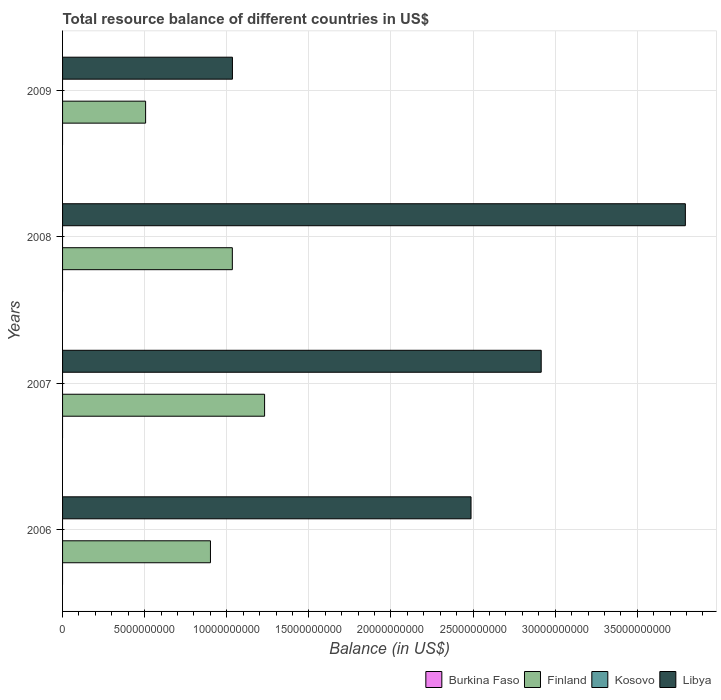How many different coloured bars are there?
Provide a short and direct response. 2. Are the number of bars on each tick of the Y-axis equal?
Provide a succinct answer. Yes. How many bars are there on the 4th tick from the top?
Your response must be concise. 2. What is the label of the 2nd group of bars from the top?
Your response must be concise. 2008. In how many cases, is the number of bars for a given year not equal to the number of legend labels?
Give a very brief answer. 4. What is the total resource balance in Finland in 2006?
Offer a terse response. 9.01e+09. Across all years, what is the maximum total resource balance in Finland?
Keep it short and to the point. 1.23e+1. Across all years, what is the minimum total resource balance in Kosovo?
Provide a short and direct response. 0. What is the difference between the total resource balance in Libya in 2006 and that in 2008?
Your answer should be very brief. -1.31e+1. What is the difference between the total resource balance in Libya in 2006 and the total resource balance in Finland in 2009?
Ensure brevity in your answer.  1.98e+1. What is the average total resource balance in Kosovo per year?
Offer a terse response. 0. In how many years, is the total resource balance in Libya greater than 12000000000 US$?
Offer a very short reply. 3. What is the ratio of the total resource balance in Libya in 2006 to that in 2008?
Give a very brief answer. 0.66. Is the total resource balance in Libya in 2007 less than that in 2008?
Your answer should be compact. Yes. What is the difference between the highest and the second highest total resource balance in Finland?
Provide a succinct answer. 1.96e+09. What is the difference between the highest and the lowest total resource balance in Libya?
Provide a succinct answer. 2.76e+1. In how many years, is the total resource balance in Burkina Faso greater than the average total resource balance in Burkina Faso taken over all years?
Provide a short and direct response. 0. Is it the case that in every year, the sum of the total resource balance in Libya and total resource balance in Finland is greater than the sum of total resource balance in Burkina Faso and total resource balance in Kosovo?
Offer a terse response. Yes. Is it the case that in every year, the sum of the total resource balance in Burkina Faso and total resource balance in Finland is greater than the total resource balance in Libya?
Give a very brief answer. No. How many bars are there?
Provide a short and direct response. 8. Are all the bars in the graph horizontal?
Your answer should be compact. Yes. What is the difference between two consecutive major ticks on the X-axis?
Your answer should be compact. 5.00e+09. Does the graph contain any zero values?
Provide a short and direct response. Yes. How many legend labels are there?
Your response must be concise. 4. What is the title of the graph?
Ensure brevity in your answer.  Total resource balance of different countries in US$. What is the label or title of the X-axis?
Your response must be concise. Balance (in US$). What is the Balance (in US$) of Burkina Faso in 2006?
Offer a terse response. 0. What is the Balance (in US$) in Finland in 2006?
Provide a succinct answer. 9.01e+09. What is the Balance (in US$) of Kosovo in 2006?
Provide a short and direct response. 0. What is the Balance (in US$) in Libya in 2006?
Your answer should be compact. 2.49e+1. What is the Balance (in US$) in Finland in 2007?
Offer a terse response. 1.23e+1. What is the Balance (in US$) in Libya in 2007?
Offer a very short reply. 2.91e+1. What is the Balance (in US$) in Finland in 2008?
Keep it short and to the point. 1.03e+1. What is the Balance (in US$) in Kosovo in 2008?
Your answer should be compact. 0. What is the Balance (in US$) of Libya in 2008?
Offer a terse response. 3.79e+1. What is the Balance (in US$) in Finland in 2009?
Provide a short and direct response. 5.06e+09. What is the Balance (in US$) in Kosovo in 2009?
Ensure brevity in your answer.  0. What is the Balance (in US$) in Libya in 2009?
Keep it short and to the point. 1.03e+1. Across all years, what is the maximum Balance (in US$) of Finland?
Ensure brevity in your answer.  1.23e+1. Across all years, what is the maximum Balance (in US$) of Libya?
Offer a terse response. 3.79e+1. Across all years, what is the minimum Balance (in US$) in Finland?
Ensure brevity in your answer.  5.06e+09. Across all years, what is the minimum Balance (in US$) in Libya?
Keep it short and to the point. 1.03e+1. What is the total Balance (in US$) in Finland in the graph?
Provide a succinct answer. 3.67e+1. What is the total Balance (in US$) in Libya in the graph?
Your answer should be compact. 1.02e+11. What is the difference between the Balance (in US$) in Finland in 2006 and that in 2007?
Offer a terse response. -3.30e+09. What is the difference between the Balance (in US$) in Libya in 2006 and that in 2007?
Make the answer very short. -4.27e+09. What is the difference between the Balance (in US$) of Finland in 2006 and that in 2008?
Ensure brevity in your answer.  -1.33e+09. What is the difference between the Balance (in US$) of Libya in 2006 and that in 2008?
Offer a terse response. -1.31e+1. What is the difference between the Balance (in US$) of Finland in 2006 and that in 2009?
Offer a very short reply. 3.95e+09. What is the difference between the Balance (in US$) in Libya in 2006 and that in 2009?
Your response must be concise. 1.45e+1. What is the difference between the Balance (in US$) in Finland in 2007 and that in 2008?
Provide a succinct answer. 1.96e+09. What is the difference between the Balance (in US$) of Libya in 2007 and that in 2008?
Your response must be concise. -8.78e+09. What is the difference between the Balance (in US$) in Finland in 2007 and that in 2009?
Ensure brevity in your answer.  7.25e+09. What is the difference between the Balance (in US$) of Libya in 2007 and that in 2009?
Provide a short and direct response. 1.88e+1. What is the difference between the Balance (in US$) in Finland in 2008 and that in 2009?
Give a very brief answer. 5.28e+09. What is the difference between the Balance (in US$) of Libya in 2008 and that in 2009?
Your answer should be compact. 2.76e+1. What is the difference between the Balance (in US$) of Finland in 2006 and the Balance (in US$) of Libya in 2007?
Your answer should be compact. -2.01e+1. What is the difference between the Balance (in US$) in Finland in 2006 and the Balance (in US$) in Libya in 2008?
Your answer should be compact. -2.89e+1. What is the difference between the Balance (in US$) in Finland in 2006 and the Balance (in US$) in Libya in 2009?
Ensure brevity in your answer.  -1.34e+09. What is the difference between the Balance (in US$) in Finland in 2007 and the Balance (in US$) in Libya in 2008?
Your response must be concise. -2.56e+1. What is the difference between the Balance (in US$) of Finland in 2007 and the Balance (in US$) of Libya in 2009?
Ensure brevity in your answer.  1.96e+09. What is the difference between the Balance (in US$) in Finland in 2008 and the Balance (in US$) in Libya in 2009?
Make the answer very short. -5.61e+06. What is the average Balance (in US$) in Finland per year?
Ensure brevity in your answer.  9.18e+09. What is the average Balance (in US$) of Kosovo per year?
Your response must be concise. 0. What is the average Balance (in US$) of Libya per year?
Make the answer very short. 2.56e+1. In the year 2006, what is the difference between the Balance (in US$) of Finland and Balance (in US$) of Libya?
Give a very brief answer. -1.59e+1. In the year 2007, what is the difference between the Balance (in US$) of Finland and Balance (in US$) of Libya?
Give a very brief answer. -1.68e+1. In the year 2008, what is the difference between the Balance (in US$) of Finland and Balance (in US$) of Libya?
Your answer should be very brief. -2.76e+1. In the year 2009, what is the difference between the Balance (in US$) in Finland and Balance (in US$) in Libya?
Offer a terse response. -5.29e+09. What is the ratio of the Balance (in US$) of Finland in 2006 to that in 2007?
Keep it short and to the point. 0.73. What is the ratio of the Balance (in US$) in Libya in 2006 to that in 2007?
Your answer should be very brief. 0.85. What is the ratio of the Balance (in US$) in Finland in 2006 to that in 2008?
Keep it short and to the point. 0.87. What is the ratio of the Balance (in US$) in Libya in 2006 to that in 2008?
Provide a succinct answer. 0.66. What is the ratio of the Balance (in US$) of Finland in 2006 to that in 2009?
Keep it short and to the point. 1.78. What is the ratio of the Balance (in US$) in Libya in 2006 to that in 2009?
Provide a short and direct response. 2.4. What is the ratio of the Balance (in US$) in Finland in 2007 to that in 2008?
Keep it short and to the point. 1.19. What is the ratio of the Balance (in US$) in Libya in 2007 to that in 2008?
Provide a short and direct response. 0.77. What is the ratio of the Balance (in US$) in Finland in 2007 to that in 2009?
Provide a succinct answer. 2.43. What is the ratio of the Balance (in US$) in Libya in 2007 to that in 2009?
Offer a terse response. 2.82. What is the ratio of the Balance (in US$) in Finland in 2008 to that in 2009?
Provide a succinct answer. 2.04. What is the ratio of the Balance (in US$) of Libya in 2008 to that in 2009?
Offer a very short reply. 3.67. What is the difference between the highest and the second highest Balance (in US$) in Finland?
Provide a succinct answer. 1.96e+09. What is the difference between the highest and the second highest Balance (in US$) of Libya?
Offer a very short reply. 8.78e+09. What is the difference between the highest and the lowest Balance (in US$) of Finland?
Offer a very short reply. 7.25e+09. What is the difference between the highest and the lowest Balance (in US$) in Libya?
Your answer should be compact. 2.76e+1. 